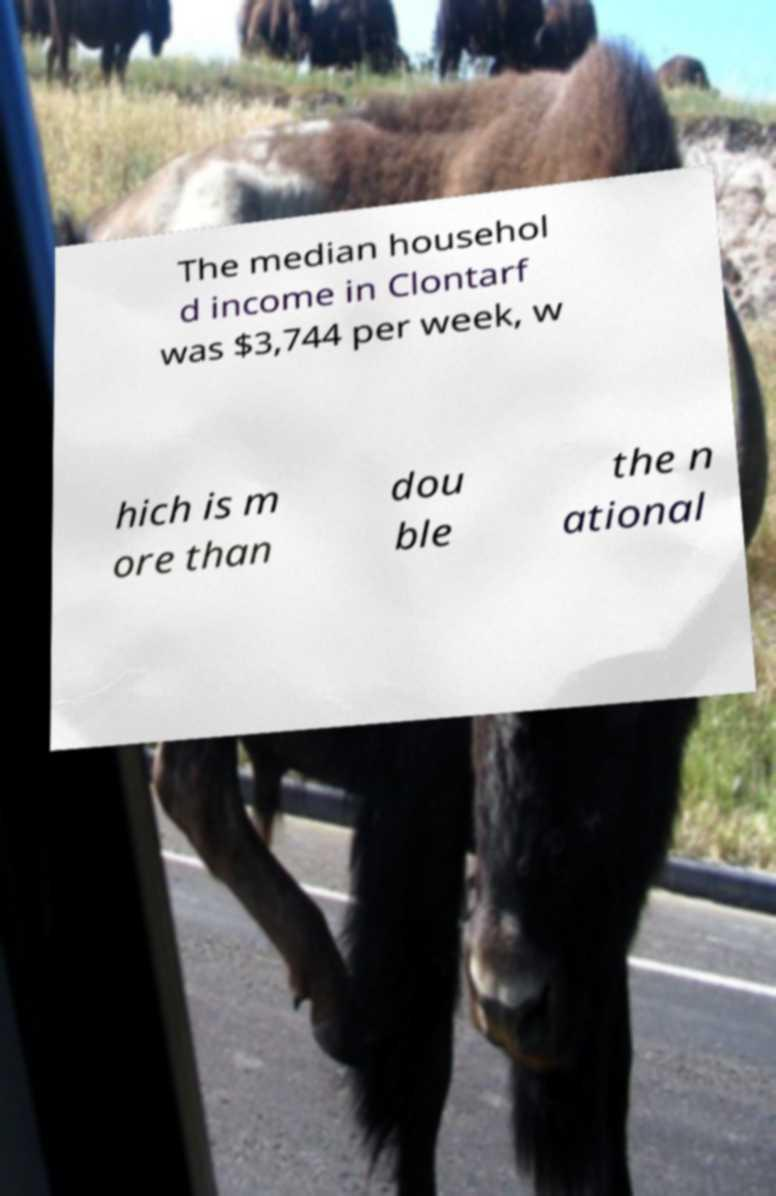Can you read and provide the text displayed in the image?This photo seems to have some interesting text. Can you extract and type it out for me? The median househol d income in Clontarf was $3,744 per week, w hich is m ore than dou ble the n ational 